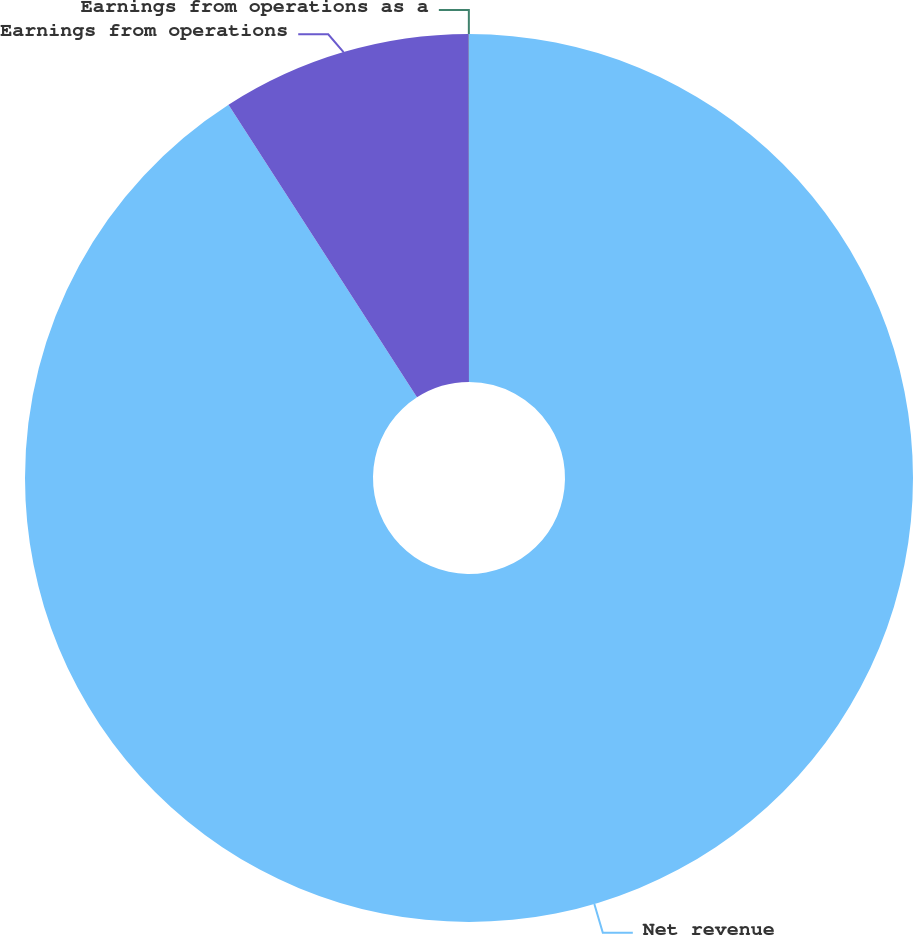Convert chart to OTSL. <chart><loc_0><loc_0><loc_500><loc_500><pie_chart><fcel>Net revenue<fcel>Earnings from operations<fcel>Earnings from operations as a<nl><fcel>90.89%<fcel>9.1%<fcel>0.01%<nl></chart> 